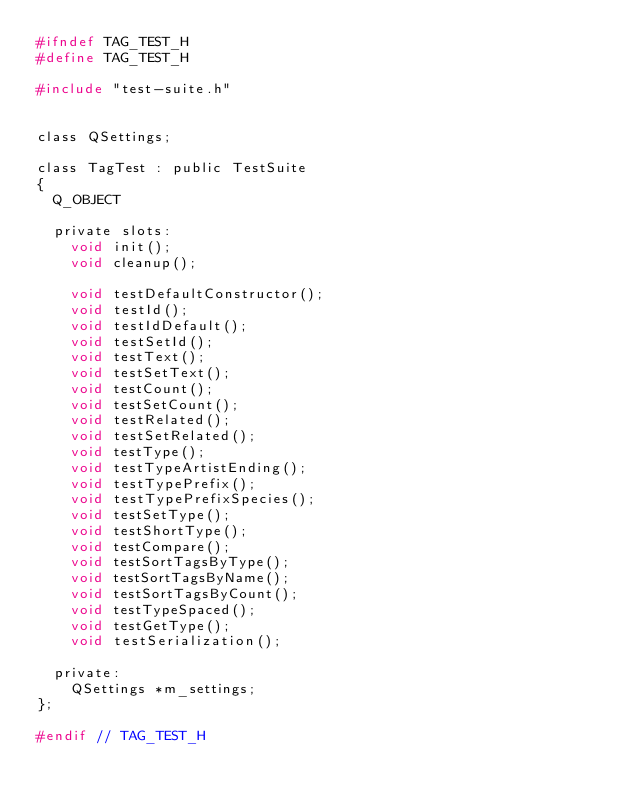<code> <loc_0><loc_0><loc_500><loc_500><_C_>#ifndef TAG_TEST_H
#define TAG_TEST_H

#include "test-suite.h"


class QSettings;

class TagTest : public TestSuite
{
	Q_OBJECT

	private slots:
		void init();
		void cleanup();

		void testDefaultConstructor();
		void testId();
		void testIdDefault();
		void testSetId();
		void testText();
		void testSetText();
		void testCount();
		void testSetCount();
		void testRelated();
		void testSetRelated();
		void testType();
		void testTypeArtistEnding();
		void testTypePrefix();
		void testTypePrefixSpecies();
		void testSetType();
		void testShortType();
		void testCompare();
		void testSortTagsByType();
		void testSortTagsByName();
		void testSortTagsByCount();
		void testTypeSpaced();
		void testGetType();
		void testSerialization();

	private:
		QSettings *m_settings;
};

#endif // TAG_TEST_H
</code> 